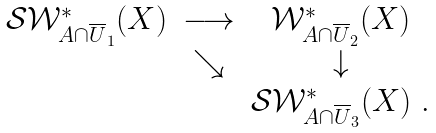Convert formula to latex. <formula><loc_0><loc_0><loc_500><loc_500>\begin{matrix} { \mathcal { S } } { \mathcal { W } } ^ { * } _ { A \cap \overline { U } _ { 1 } } ( X ) & \longrightarrow & { \mathcal { W } } ^ { * } _ { A \cap \overline { U } _ { 2 } } ( X ) \\ & \searrow & \downarrow \\ & & { \mathcal { S } } { \mathcal { W } } ^ { * } _ { A \cap \overline { U } _ { 3 } } ( X ) \ . \end{matrix}</formula> 